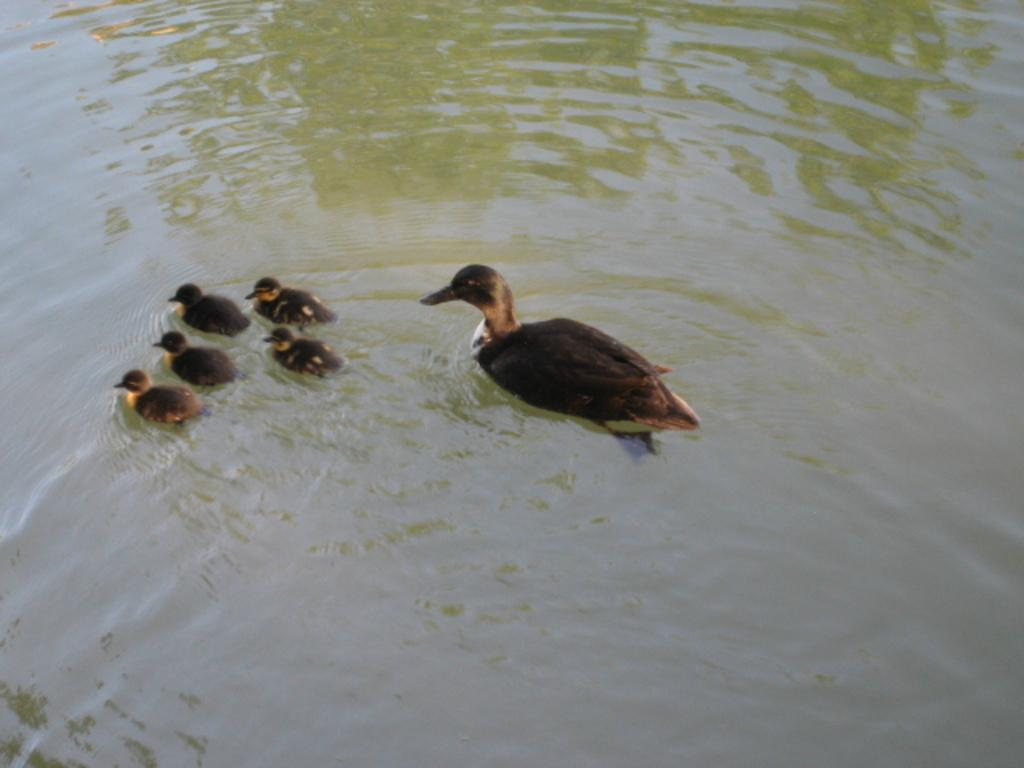What type of animals can be seen in the image? Birds can be seen in the water in the image. What is the primary element in which the birds are situated? The birds are situated in water in the image. Can you see any ghosts interacting with the birds in the image? There are no ghosts present in the image; it features birds in the water. What type of produce can be seen growing near the birds in the image? There is no produce visible in the image; it only features birds in the water. 